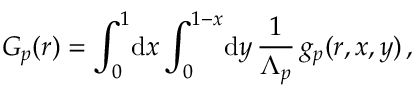<formula> <loc_0><loc_0><loc_500><loc_500>G _ { p } ( r ) = \int _ { 0 } ^ { 1 } \, d x \int _ { 0 } ^ { 1 - x } \, d y \, \frac { 1 } \Lambda _ { p } } \, g _ { p } ( r , x , y ) \, ,</formula> 